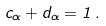<formula> <loc_0><loc_0><loc_500><loc_500>c _ { \alpha } + d _ { \alpha } = 1 \, .</formula> 